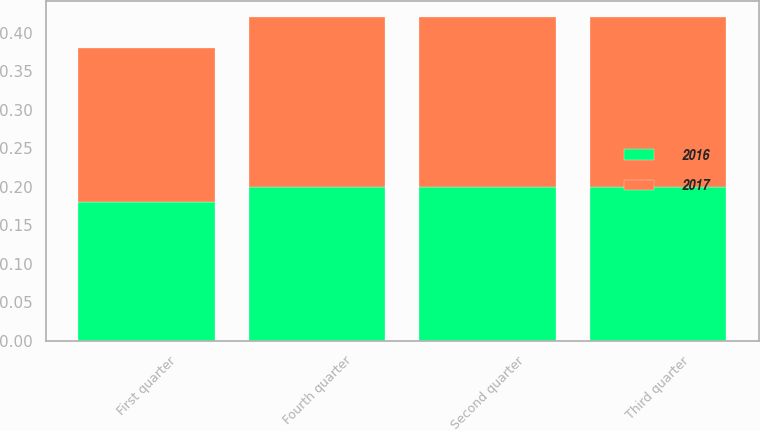Convert chart. <chart><loc_0><loc_0><loc_500><loc_500><stacked_bar_chart><ecel><fcel>First quarter<fcel>Second quarter<fcel>Third quarter<fcel>Fourth quarter<nl><fcel>2017<fcel>0.2<fcel>0.22<fcel>0.22<fcel>0.22<nl><fcel>2016<fcel>0.18<fcel>0.2<fcel>0.2<fcel>0.2<nl></chart> 